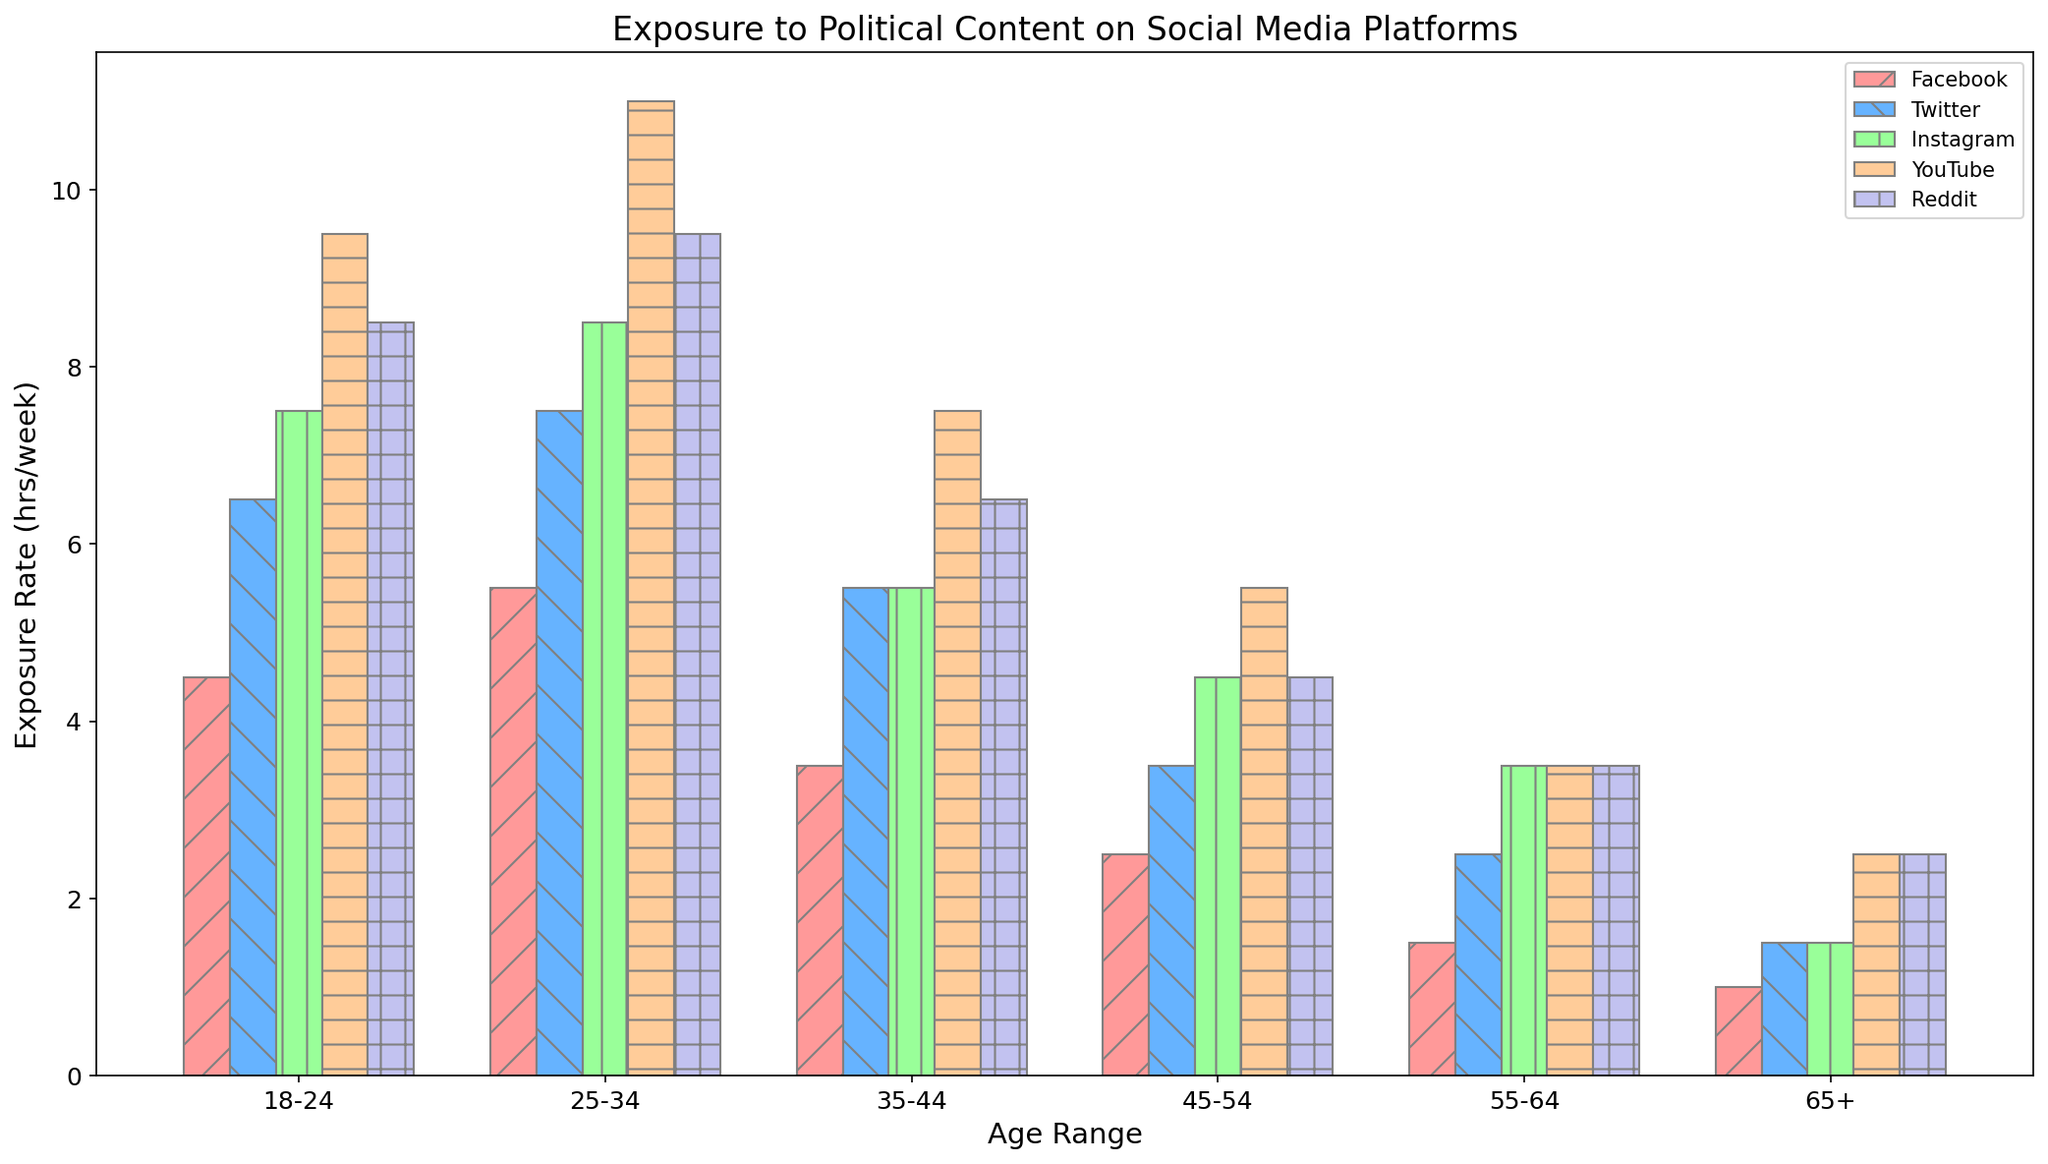What's the average exposure rate on YouTube for the 25-34 age group? Look at the bars for the 25-34 age group on YouTube. The average is calculated by taking the values for males (12 hrs/week) and females (10 hrs/week), summing them (12 + 10 = 22), and dividing by 2.
Answer: 11 hrs/week Which age group has the highest exposure rate for Facebook? Refer to the height of the bars for Facebook across all age groups. The highest bar indicates the age group with the highest exposure. The 25-34 group has the highest rate, with males at 6 hrs/week and females at 5 hrs/week.
Answer: 25-34 By how many hours per week does the 18-24 age group’s exposure on Twitter exceed the 45-54 age group? Compare the heights of the bars for 18-24 and 45-54 on Twitter. For 18-24, males (7 hrs/week) and females (6 hrs/week). For 45-54, males (4 hrs/week) and females (3 hrs/week). Calculate the average exposure for each group: (7+6)/2 = 6.5 hrs/week and (4+3)/2 = 3.5 hrs/week. The difference is 6.5 - 3.5.
Answer: 3 hrs/week Which platform shows the lowest exposure rate among the 35-44 female group? Look at the bars representing the 35-44 female group's exposure on each platform. The shortest bar indicates the lowest exposure rate. The Facebook bar is the shortest at 3 hrs/week.
Answer: Facebook Are the exposure rates for Instagram equal for males and females in the 65+ group? Check the heights of the bars for the 65+ group on Instagram. For males, the rate is 1 hr/week and for females, it is 2 hrs/week. The heights are not equal.
Answer: No What's the total exposure rate for males in the 55-64 age group across all platforms? Refer to the bars for males in the 55-64 age group on all platforms. Sum the values: Facebook 2 + Twitter 3 + Instagram 4 + YouTube 4 + Reddit 4. The total is 2+3+4+4+4.
Answer: 17 hrs/week Which gender has more exposure on Reddit for the 18-24 age group, and by how many hours? Check the bars for both males and females in the 18-24 age group on Reddit. Males have 9 hrs/week, while females have 8 hrs/week. The difference is 9 - 8.
Answer: Males, by 1 hr/week 